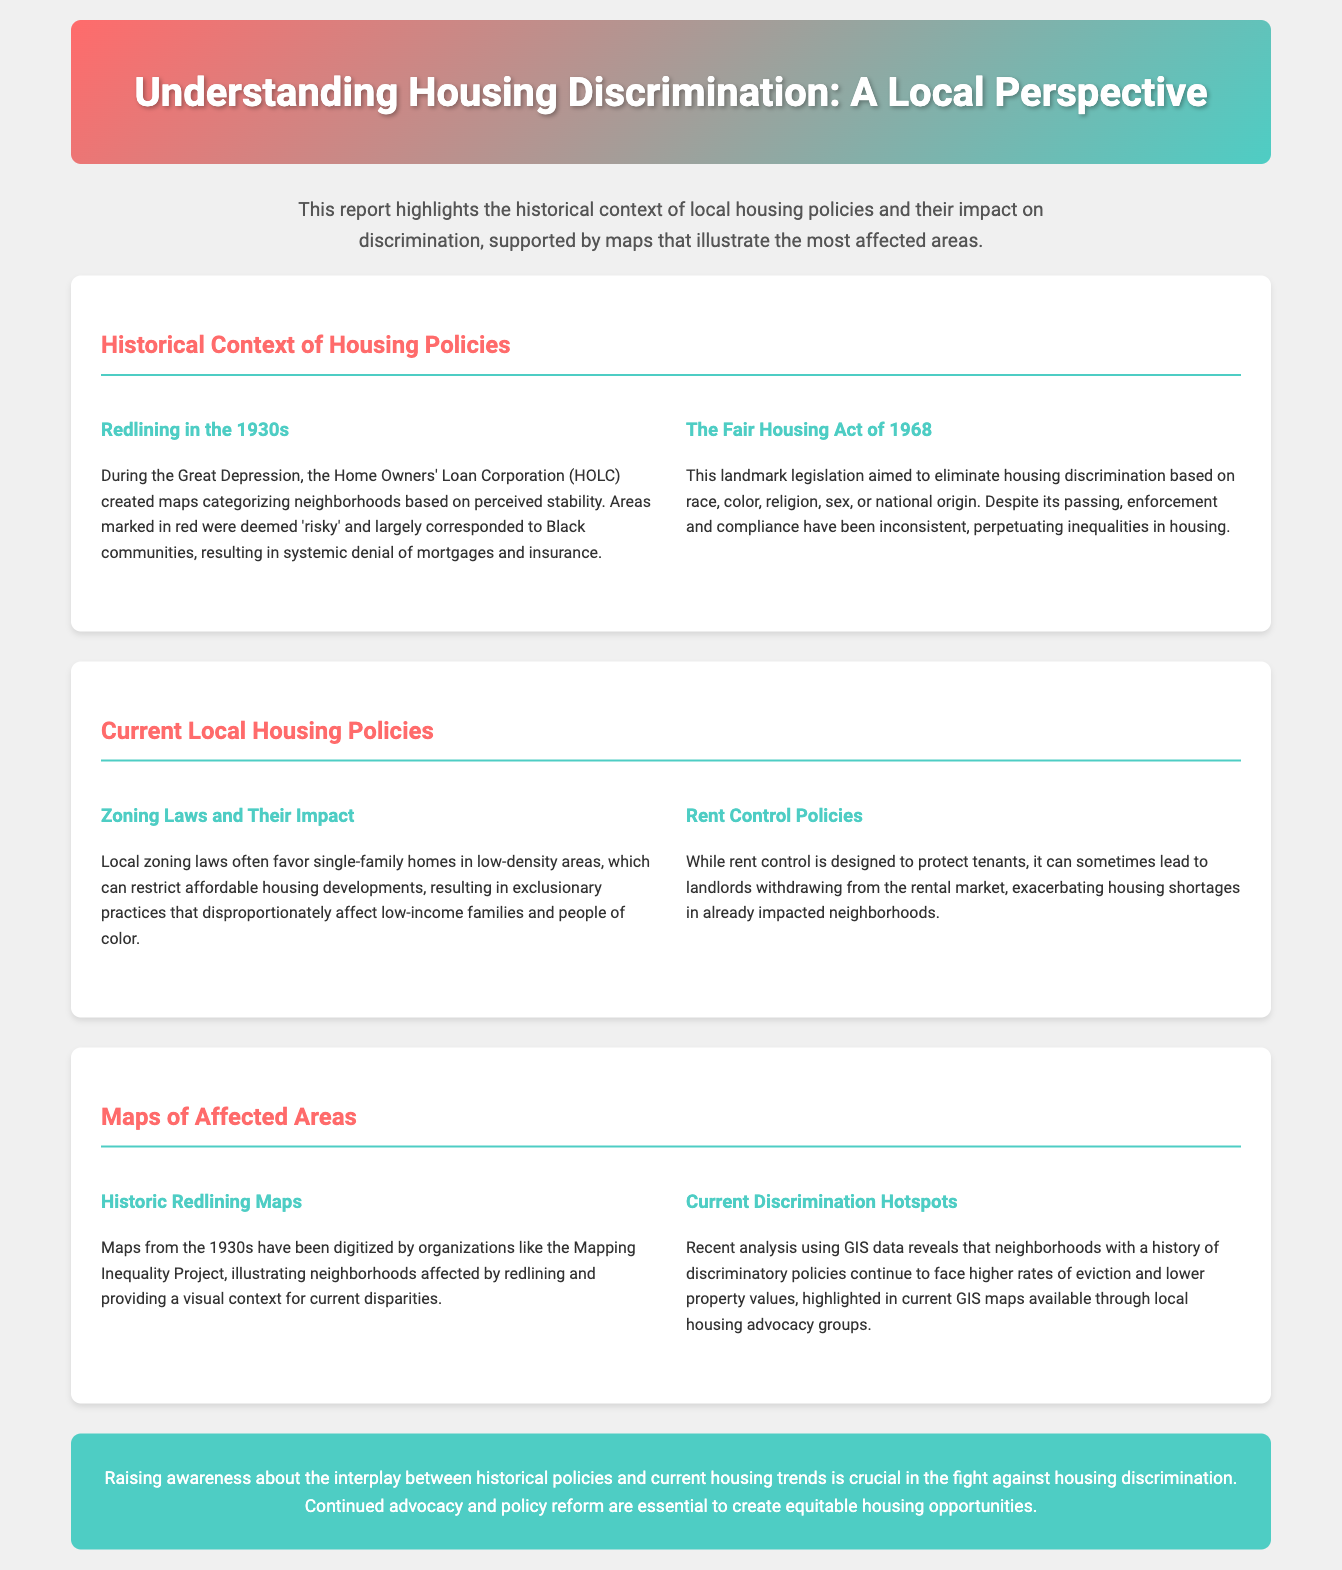what legislation aimed to eliminate housing discrimination? The document states that the Fair Housing Act of 1968 aimed to eliminate housing discrimination.
Answer: Fair Housing Act of 1968 what were the main maps created by HOLC in the 1930s? The document mentions redlining maps created by HOLC during the 1930s.
Answer: Redlining maps what is a significant historical housing policy from the 1930s? The document highlights redlining as a significant historical policy from the 1930s.
Answer: Redlining what does the report suggest about current zoning laws? The document discusses that zoning laws often favor single-family homes, impacting affordable housing.
Answer: Favor single-family homes how were neighborhoods categorized in the 1930s? According to the document, neighborhoods were categorized based on perceived stability by HOLC.
Answer: Based on perceived stability what does the report indicate about rent control policies? The document states that rent control can lead to landlords withdrawing from the rental market.
Answer: Landlords withdrawing what are "discrimination hotspots" according to the report? The document refers to neighborhoods with a history of discriminatory policies facing higher rates of eviction.
Answer: Higher rates of eviction what role do current GIS maps play in the report? The document mentions that current GIS maps highlight neighborhoods affected by historical discrimination policies.
Answer: Highlight neighborhoods what is the document's primary purpose? The document aims to raise awareness about the interplay between historical policies and current housing trends.
Answer: Raise awareness 